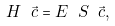Convert formula to latex. <formula><loc_0><loc_0><loc_500><loc_500>H \ \vec { c } = E \ S \ \vec { c } ,</formula> 